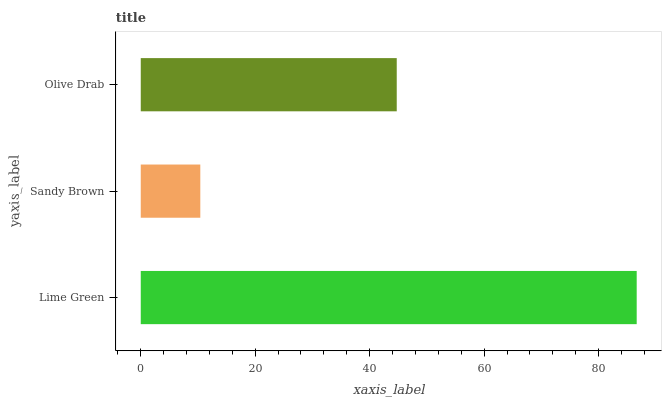Is Sandy Brown the minimum?
Answer yes or no. Yes. Is Lime Green the maximum?
Answer yes or no. Yes. Is Olive Drab the minimum?
Answer yes or no. No. Is Olive Drab the maximum?
Answer yes or no. No. Is Olive Drab greater than Sandy Brown?
Answer yes or no. Yes. Is Sandy Brown less than Olive Drab?
Answer yes or no. Yes. Is Sandy Brown greater than Olive Drab?
Answer yes or no. No. Is Olive Drab less than Sandy Brown?
Answer yes or no. No. Is Olive Drab the high median?
Answer yes or no. Yes. Is Olive Drab the low median?
Answer yes or no. Yes. Is Lime Green the high median?
Answer yes or no. No. Is Lime Green the low median?
Answer yes or no. No. 